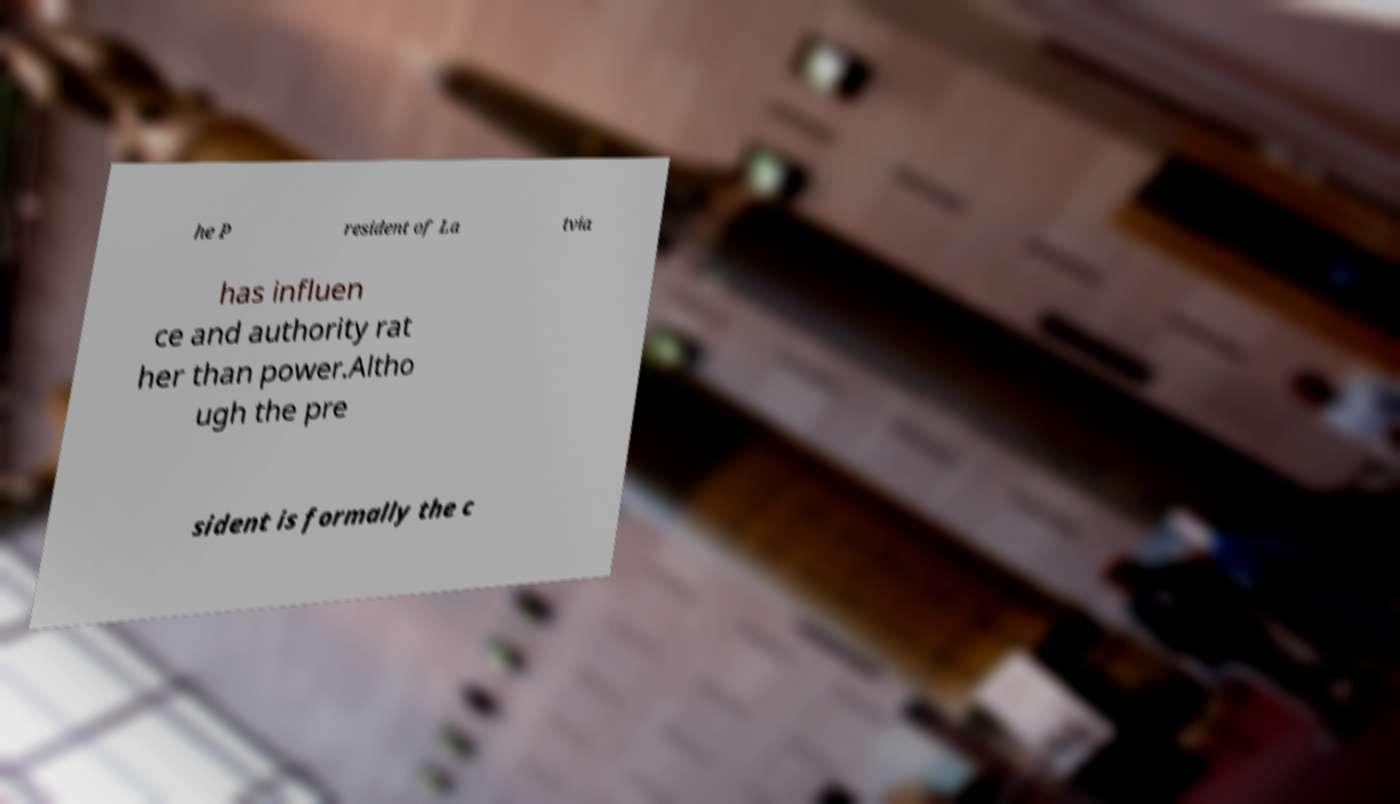Could you assist in decoding the text presented in this image and type it out clearly? he P resident of La tvia has influen ce and authority rat her than power.Altho ugh the pre sident is formally the c 